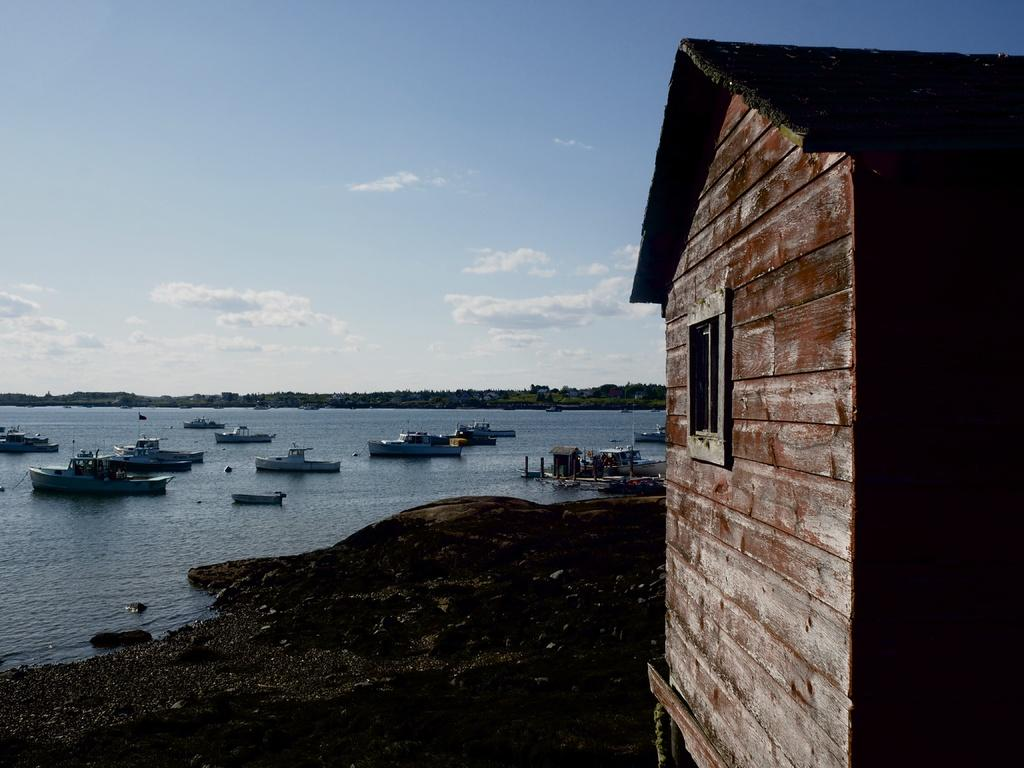What type of structure is present in the image? There is a house in the image. What can be seen in the background of the image? Boats are visible in the background of the image, and there is water present as well. How would you describe the sky in the image? The sky is visible in the image, with a combination of white and blue colors. What type of rake is being used by the person in the image? There is no person or rake present in the image. What book is the person reading in the image? There is no person or book present in the image. 